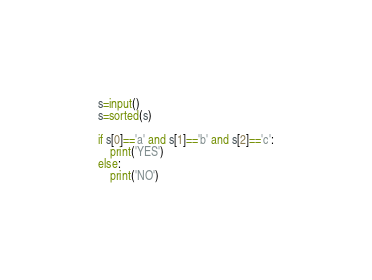Convert code to text. <code><loc_0><loc_0><loc_500><loc_500><_Python_>s=input()
s=sorted(s)

if s[0]=='a' and s[1]=='b' and s[2]=='c':
    print('YES')
else:
    print('NO')</code> 